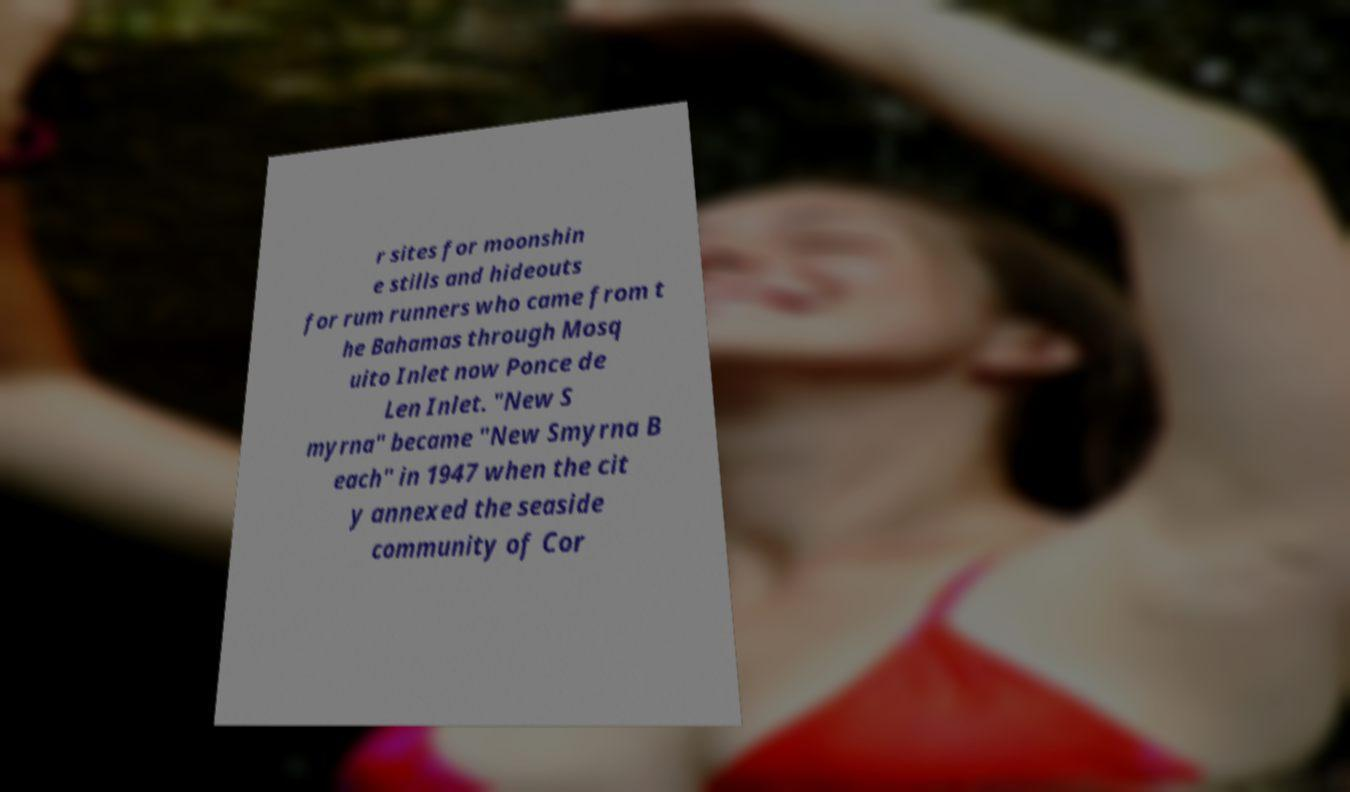There's text embedded in this image that I need extracted. Can you transcribe it verbatim? r sites for moonshin e stills and hideouts for rum runners who came from t he Bahamas through Mosq uito Inlet now Ponce de Len Inlet. "New S myrna" became "New Smyrna B each" in 1947 when the cit y annexed the seaside community of Cor 